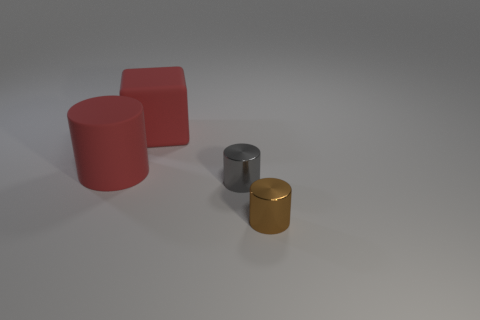Is the color of the big rubber block to the left of the brown shiny cylinder the same as the big matte cylinder?
Keep it short and to the point. Yes. There is a object that is the same color as the block; what is its material?
Provide a succinct answer. Rubber. Does the thing that is in front of the gray thing have the same size as the red block?
Give a very brief answer. No. Is there a rubber sphere of the same color as the block?
Make the answer very short. No. There is a large red object that is left of the red matte block; is there a object to the right of it?
Keep it short and to the point. Yes. Are there any tiny gray things that have the same material as the tiny brown cylinder?
Your response must be concise. Yes. There is a big red object that is on the left side of the red rubber block that is on the left side of the tiny gray metallic cylinder; what is its material?
Offer a terse response. Rubber. What is the object that is in front of the red cube and behind the gray shiny cylinder made of?
Give a very brief answer. Rubber. Are there the same number of gray things that are in front of the gray thing and gray spheres?
Make the answer very short. Yes. What number of other big objects are the same shape as the gray object?
Offer a very short reply. 1. 